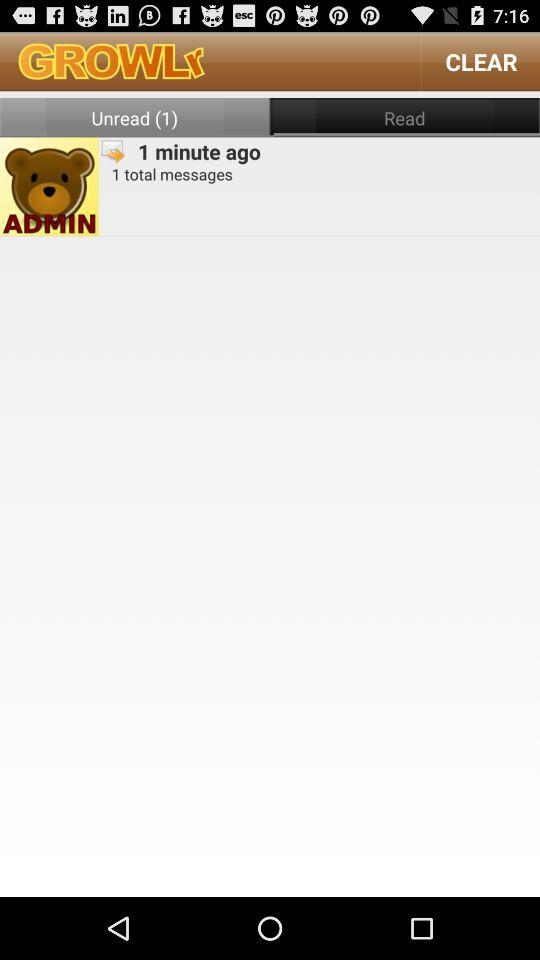How many unread messages are there?
Answer the question using a single word or phrase. 1 